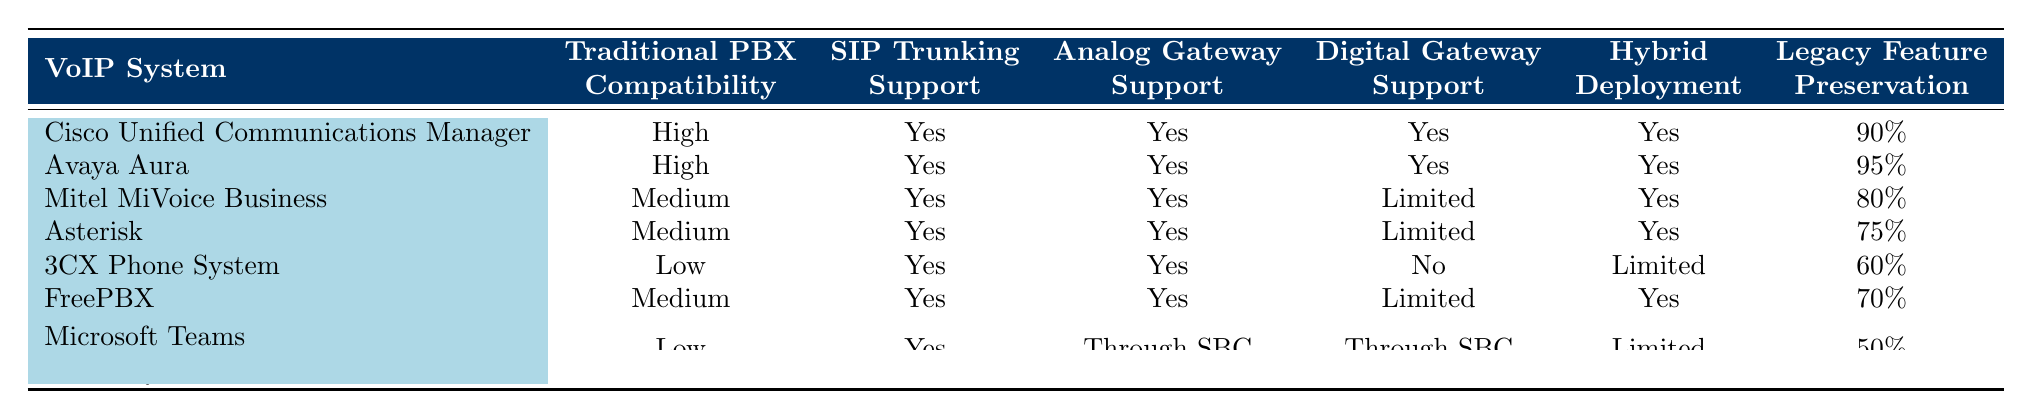What is the traditional PBX compatibility for Avaya Aura? According to the table, Avaya Aura has a compatibility rating of "High" with traditional PBX systems.
Answer: High Which VoIP system has the highest legacy feature preservation? By examining the "Legacy Feature Preservation" column, Avaya Aura shows the highest percentage at 95%.
Answer: 95% Does the 3CX Phone System support digital gateways? The table indicates that the 3CX Phone System has "No" support for digital gateways.
Answer: No What is the average legacy feature preservation percentage of the VoIP systems listed? Summing the percentages of legacy feature preservation gives 90 + 95 + 80 + 75 + 60 + 70 + 50 = 520. There are 7 VoIP systems, so the average is 520/7 ≈ 74.29%.
Answer: 74.29% Which VoIP systems are compatible with analog gateways? The table lists Cisco Unified Communications Manager, Avaya Aura, Mitel MiVoice Business, Asterisk, 3CX Phone System, and FreePBX as having support for analog gateways.
Answer: Cisco, Avaya, Mitel, Asterisk, 3CX, FreePBX What is the difference in traditional PBX compatibility between the highest and lowest rated systems? The highest compatibility is "High" (Avaya Aura, Cisco Unified Communications Manager) and the lowest is "Low" (Microsoft Teams and 3CX), thus the difference in ratings is from "High" to "Low."
Answer: High to Low Is SIP trunking support available for all VoIP systems listed in the table? The table shows that all listed VoIP systems provide support for SIP trunking with a "Yes" for each system.
Answer: Yes How many VoIP systems have medium traditional PBX compatibility? Three systems have medium traditional PBX compatibility: Mitel MiVoice Business, Asterisk, and FreePBX.
Answer: 3 Which VoIP system has limited digital gateway support? Both Mitel MiVoice Business and Asterisk are listed with "Limited" digital gateway support.
Answer: Mitel MiVoice Business, Asterisk 